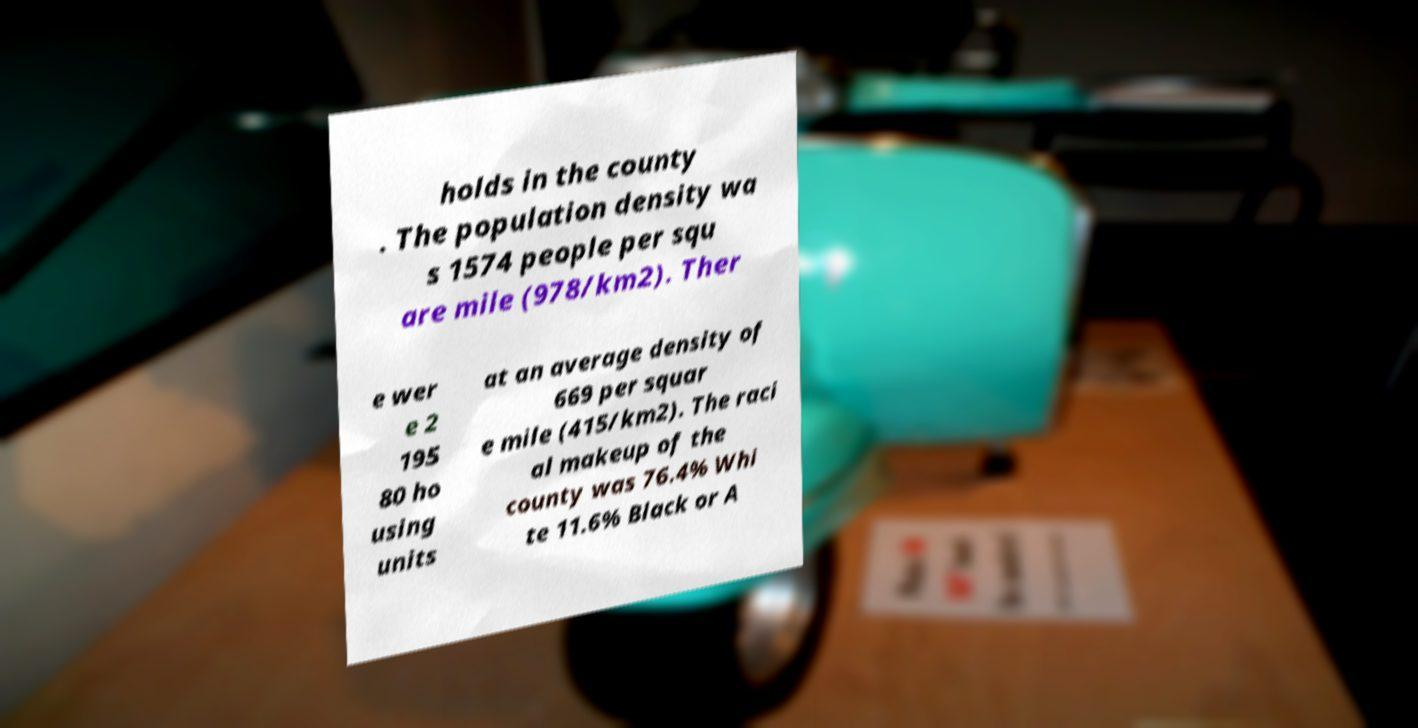Can you accurately transcribe the text from the provided image for me? holds in the county . The population density wa s 1574 people per squ are mile (978/km2). Ther e wer e 2 195 80 ho using units at an average density of 669 per squar e mile (415/km2). The raci al makeup of the county was 76.4% Whi te 11.6% Black or A 